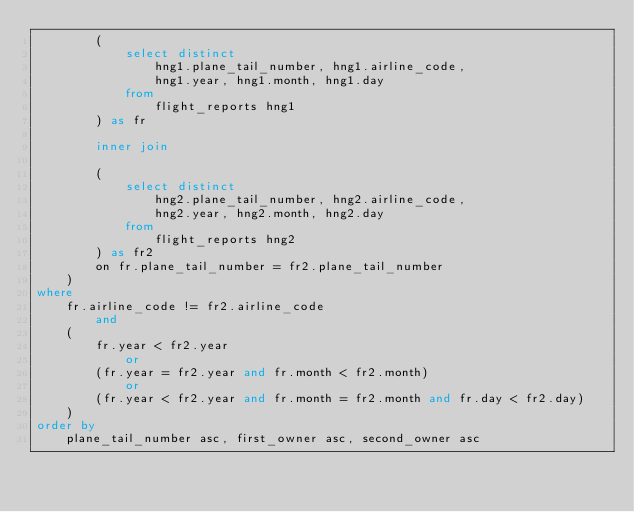Convert code to text. <code><loc_0><loc_0><loc_500><loc_500><_SQL_>		(
			select distinct 
				hng1.plane_tail_number, hng1.airline_code,
				hng1.year, hng1.month, hng1.day
			from
				flight_reports hng1
		) as fr
		
		inner join
		
		(
			select distinct
				hng2.plane_tail_number, hng2.airline_code, 
				hng2.year, hng2.month, hng2.day
			from
				flight_reports hng2
		) as fr2
		on fr.plane_tail_number = fr2.plane_tail_number 
	)
where
	fr.airline_code != fr2.airline_code 
		and
	(
		fr.year < fr2.year
			or
		(fr.year = fr2.year and fr.month < fr2.month)
			or
		(fr.year < fr2.year and fr.month = fr2.month and fr.day < fr2.day)	
	)
order by
	plane_tail_number asc, first_owner asc, second_owner asc</code> 